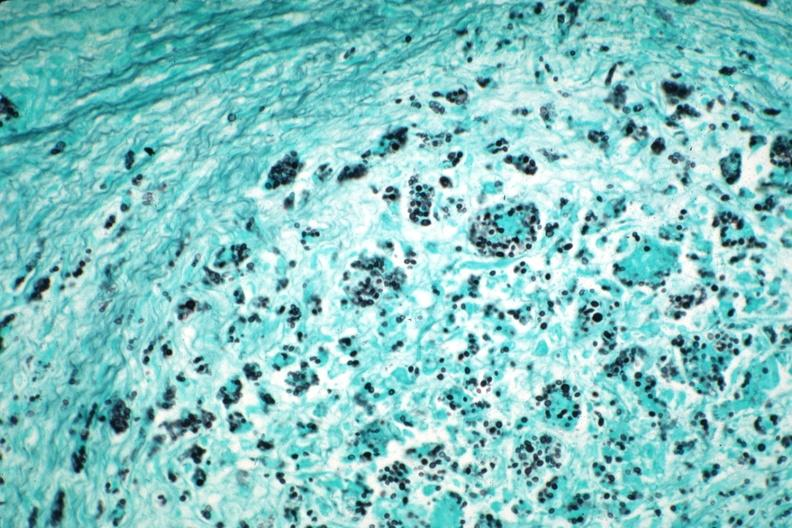does this image show gms illustrates organisms granulomatous prostatitis case of aids?
Answer the question using a single word or phrase. Yes 